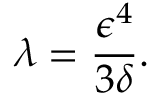<formula> <loc_0><loc_0><loc_500><loc_500>\lambda = \frac { \epsilon ^ { 4 } } { 3 \delta } .</formula> 